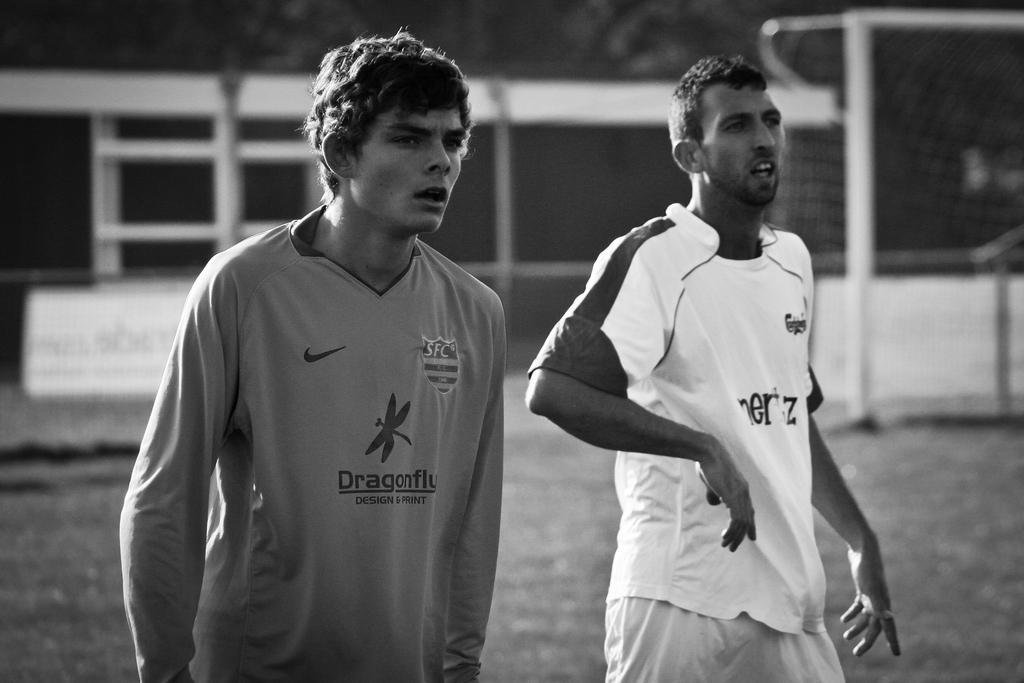In one or two sentences, can you explain what this image depicts? This is a black and white image. In this image there are two men. In the background it is blurred. Also there are some poles. 